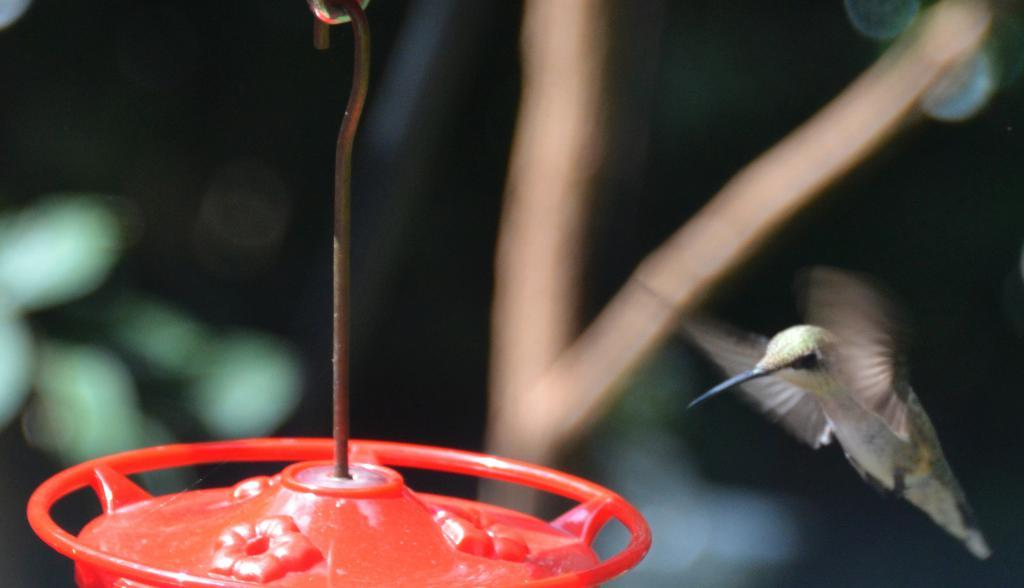What type of animal can be seen in the image? There is a bird in the image. What is the color of the object hanging in the image? The object hanging in the image is red. Can you describe the background of the image? The background of the image is blurred. What type of chess piece is visible in the image? There is no chess piece present in the image. How many boats can be seen sailing in the image? There are no boats visible in the image. 